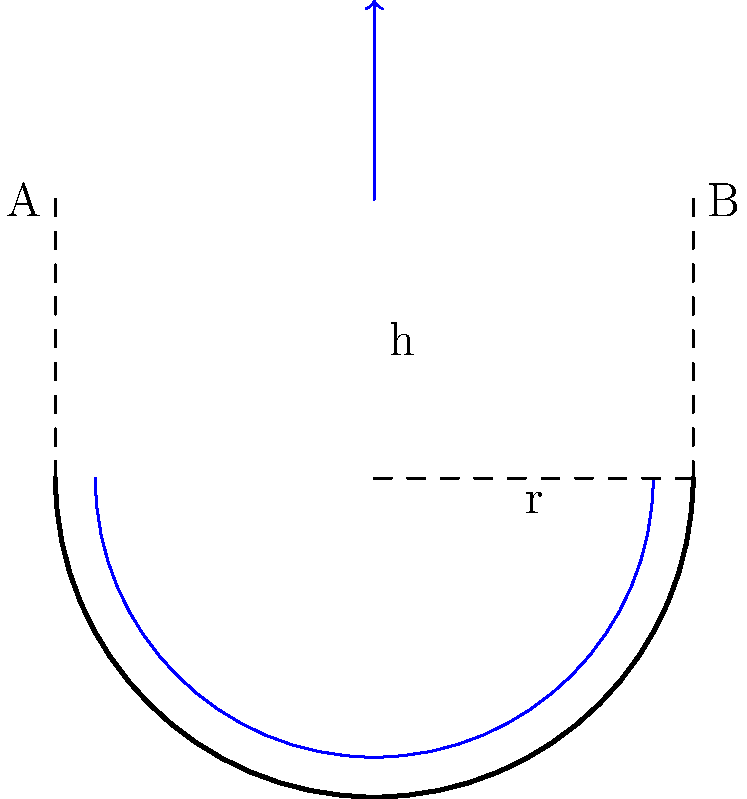In your backyard bird bath fountain, you notice that the water flow creates a circular pattern. If the radius of the bird bath is 30 cm and the water depth is 10 cm, what is the maximum velocity of the water at the edge of the bath to prevent birds from being startled? Assume the water rotates as a solid body and use $g = 9.81 \text{ m/s}^2$. To solve this problem, we'll use the concept of solid body rotation in fluid dynamics. Here's a step-by-step approach:

1) In solid body rotation, the angular velocity ($\omega$) is constant throughout the fluid.

2) The maximum velocity occurs at the edge of the bird bath (point B in the diagram).

3) The relationship between linear velocity ($v$) and angular velocity ($\omega$) is:
   
   $$v = \omega r$$

   where $r$ is the radius of the bird bath.

4) To find $\omega$, we can use the equation for the shape of the free surface in solid body rotation:

   $$h = \frac{\omega^2 r^2}{2g}$$

   where $h$ is the height difference between the center and edge of the rotating fluid, and $g$ is the acceleration due to gravity.

5) In our case, $h = 10 \text{ cm} = 0.1 \text{ m}$, $r = 30 \text{ cm} = 0.3 \text{ m}$, and $g = 9.81 \text{ m/s}^2$.

6) Substituting these values:

   $$0.1 = \frac{\omega^2 (0.3)^2}{2(9.81)}$$

7) Solving for $\omega$:

   $$\omega = \sqrt{\frac{2(9.81)(0.1)}{(0.3)^2}} = 2.55 \text{ rad/s}$$

8) Now we can find the maximum velocity at the edge:

   $$v = \omega r = 2.55 \times 0.3 = 0.765 \text{ m/s}$$

9) To prevent startling the birds, we should round this down to a more conservative value, say 0.75 m/s or 75 cm/s.
Answer: 75 cm/s 